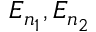Convert formula to latex. <formula><loc_0><loc_0><loc_500><loc_500>E _ { n _ { 1 } } , E _ { n _ { 2 } }</formula> 